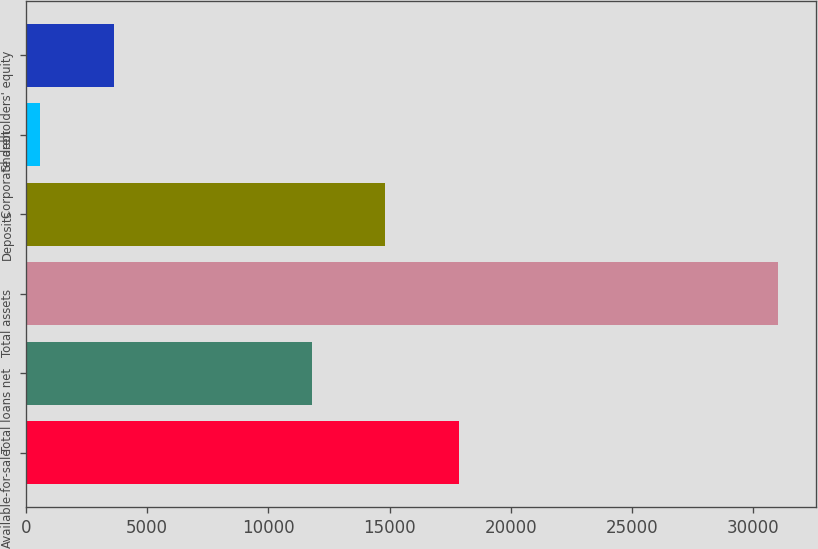Convert chart. <chart><loc_0><loc_0><loc_500><loc_500><bar_chart><fcel>Available-for-sale<fcel>Total loans net<fcel>Total assets<fcel>Deposits<fcel>Corporate debt<fcel>Shareholders' equity<nl><fcel>17874.4<fcel>11785<fcel>31032.6<fcel>14829.7<fcel>585.6<fcel>3630.3<nl></chart> 